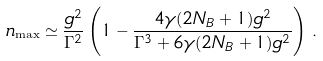Convert formula to latex. <formula><loc_0><loc_0><loc_500><loc_500>n _ { \max } \simeq \frac { g ^ { 2 } } { \Gamma ^ { 2 } } \left ( 1 - \frac { 4 \gamma ( 2 N _ { B } + 1 ) g ^ { 2 } } { \Gamma ^ { 3 } + 6 \gamma ( 2 N _ { B } + 1 ) g ^ { 2 } } \right ) \, .</formula> 